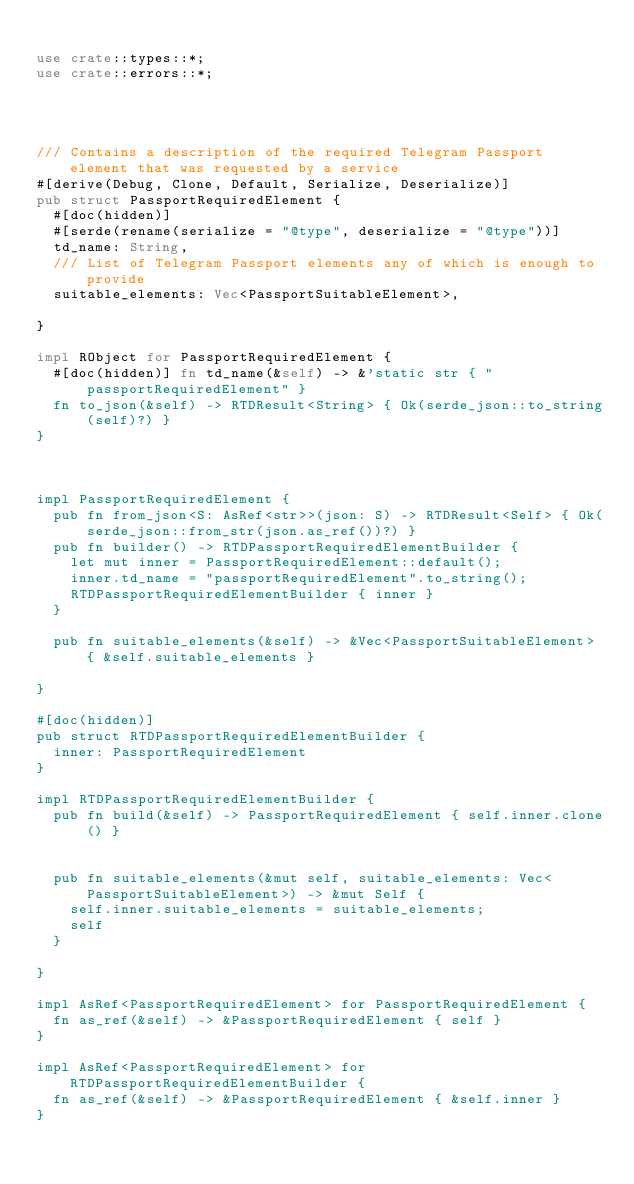<code> <loc_0><loc_0><loc_500><loc_500><_Rust_>
use crate::types::*;
use crate::errors::*;




/// Contains a description of the required Telegram Passport element that was requested by a service
#[derive(Debug, Clone, Default, Serialize, Deserialize)]
pub struct PassportRequiredElement {
  #[doc(hidden)]
  #[serde(rename(serialize = "@type", deserialize = "@type"))]
  td_name: String,
  /// List of Telegram Passport elements any of which is enough to provide
  suitable_elements: Vec<PassportSuitableElement>,
  
}

impl RObject for PassportRequiredElement {
  #[doc(hidden)] fn td_name(&self) -> &'static str { "passportRequiredElement" }
  fn to_json(&self) -> RTDResult<String> { Ok(serde_json::to_string(self)?) }
}



impl PassportRequiredElement {
  pub fn from_json<S: AsRef<str>>(json: S) -> RTDResult<Self> { Ok(serde_json::from_str(json.as_ref())?) }
  pub fn builder() -> RTDPassportRequiredElementBuilder {
    let mut inner = PassportRequiredElement::default();
    inner.td_name = "passportRequiredElement".to_string();
    RTDPassportRequiredElementBuilder { inner }
  }

  pub fn suitable_elements(&self) -> &Vec<PassportSuitableElement> { &self.suitable_elements }

}

#[doc(hidden)]
pub struct RTDPassportRequiredElementBuilder {
  inner: PassportRequiredElement
}

impl RTDPassportRequiredElementBuilder {
  pub fn build(&self) -> PassportRequiredElement { self.inner.clone() }

   
  pub fn suitable_elements(&mut self, suitable_elements: Vec<PassportSuitableElement>) -> &mut Self {
    self.inner.suitable_elements = suitable_elements;
    self
  }

}

impl AsRef<PassportRequiredElement> for PassportRequiredElement {
  fn as_ref(&self) -> &PassportRequiredElement { self }
}

impl AsRef<PassportRequiredElement> for RTDPassportRequiredElementBuilder {
  fn as_ref(&self) -> &PassportRequiredElement { &self.inner }
}



</code> 